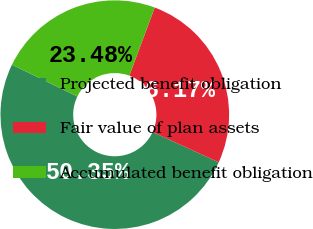Convert chart. <chart><loc_0><loc_0><loc_500><loc_500><pie_chart><fcel>Projected benefit obligation<fcel>Fair value of plan assets<fcel>Accumulated benefit obligation<nl><fcel>50.35%<fcel>26.17%<fcel>23.48%<nl></chart> 